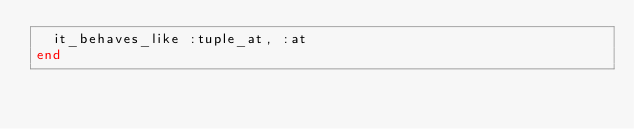<code> <loc_0><loc_0><loc_500><loc_500><_Ruby_>  it_behaves_like :tuple_at, :at
end
</code> 